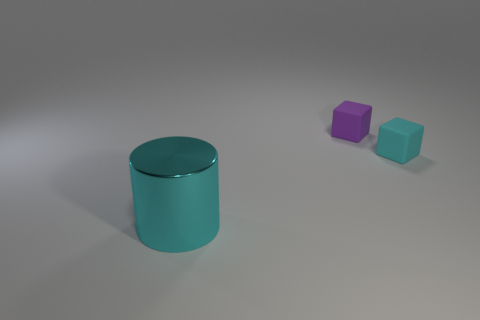Is there anything else that is the same material as the large cyan cylinder?
Provide a succinct answer. No. What material is the object that is both in front of the tiny purple object and to the right of the large thing?
Provide a short and direct response. Rubber. How many things are either small cyan things or big blue rubber objects?
Provide a succinct answer. 1. Is the number of tiny matte blocks greater than the number of tiny gray cubes?
Keep it short and to the point. Yes. What size is the cyan object in front of the cyan thing behind the cyan metallic cylinder?
Provide a short and direct response. Large. The other small thing that is the same shape as the purple rubber object is what color?
Your answer should be very brief. Cyan. The metal thing is what size?
Your answer should be very brief. Large. What number of cylinders are large cyan metal things or cyan objects?
Make the answer very short. 1. There is another thing that is the same shape as the small purple thing; what size is it?
Keep it short and to the point. Small. What number of rubber blocks are there?
Keep it short and to the point. 2. 